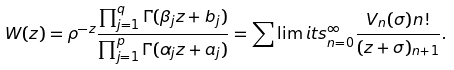<formula> <loc_0><loc_0><loc_500><loc_500>W ( z ) = \rho ^ { - z } \frac { \prod _ { j = 1 } ^ { q } \Gamma ( \beta _ { j } z + b _ { j } ) } { \prod _ { j = 1 } ^ { p } \Gamma ( \alpha _ { j } z + a _ { j } ) } = \sum \lim i t s _ { n = 0 } ^ { \infty } \frac { V _ { n } ( \sigma ) n ! } { ( z + \sigma ) _ { n + 1 } } .</formula> 